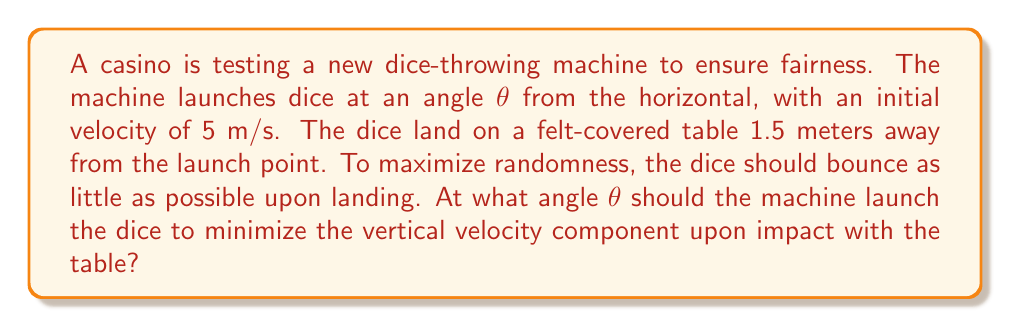Can you solve this math problem? To solve this problem, we'll use projectile motion equations and trigonometry. We want to minimize the vertical velocity component at landing, which occurs when the dice just reach the table at the end of their trajectory.

1) First, let's establish our equations:
   Horizontal distance: $x = v_0 \cos(\theta) \cdot t$
   Vertical distance: $y = v_0 \sin(\theta) \cdot t - \frac{1}{2}gt^2$

   Where $v_0 = 5$ m/s, $g = 9.8$ m/s², $x = 1.5$ m, and $y = 0$ m (at landing).

2) From the horizontal distance equation, we can find the time of flight:
   $t = \frac{x}{v_0 \cos(\theta)} = \frac{1.5}{5 \cos(\theta)}$

3) Substitute this into the vertical distance equation:
   $0 = 5 \sin(\theta) \cdot \frac{1.5}{5 \cos(\theta)} - \frac{1}{2}(9.8)(\frac{1.5}{5 \cos(\theta)})^2$

4) Simplify:
   $0 = 1.5 \tan(\theta) - \frac{1.323}{\cos^2(\theta)}$

5) Multiply both sides by $\cos^2(\theta)$:
   $0 = 1.5 \sin(\theta)\cos(\theta) - 1.323$

6) Use the double angle formula: $\sin(2\theta) = 2\sin(\theta)\cos(\theta)$
   $0 = 0.75 \sin(2\theta) - 1.323$

7) Solve for $\sin(2\theta)$:
   $\sin(2\theta) = \frac{1.323}{0.75} = 1.764$

8) Take the inverse sine:
   $2\theta = \arcsin(1.764) = 70.53°$

9) Solve for θ:
   $\theta = 35.26°$

This angle minimizes the vertical velocity component upon landing, ensuring the dice have the least tendency to bounce, thus maximizing randomness.
Answer: $\theta = 35.26°$ 